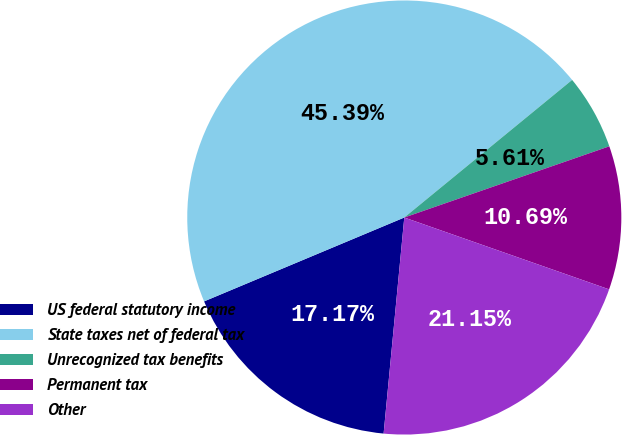<chart> <loc_0><loc_0><loc_500><loc_500><pie_chart><fcel>US federal statutory income<fcel>State taxes net of federal tax<fcel>Unrecognized tax benefits<fcel>Permanent tax<fcel>Other<nl><fcel>17.17%<fcel>45.39%<fcel>5.61%<fcel>10.69%<fcel>21.15%<nl></chart> 